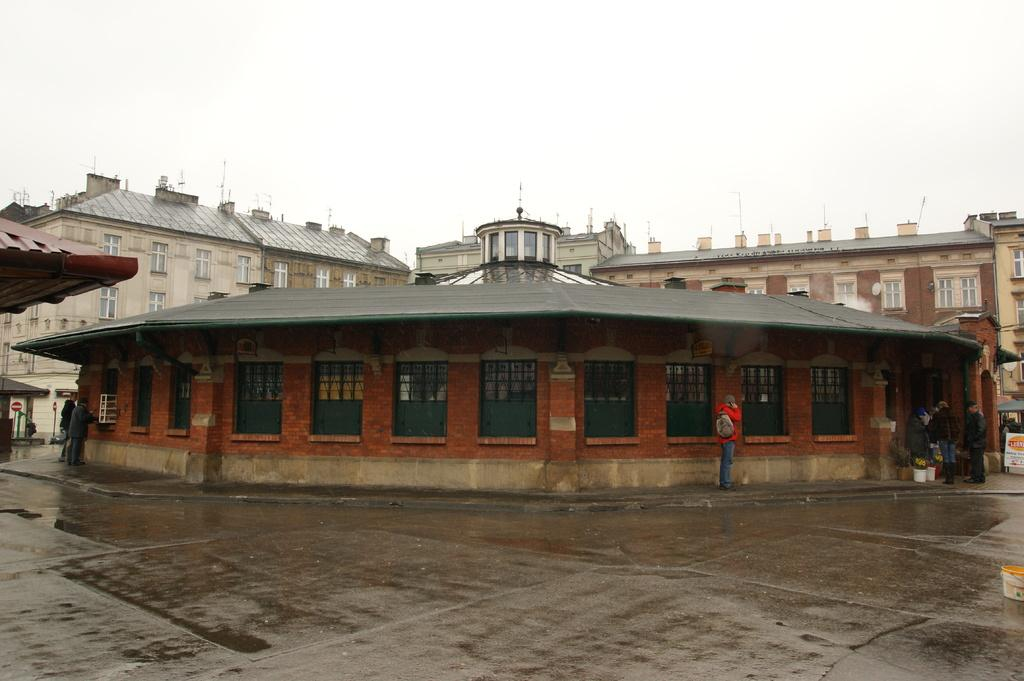What type of structures are visible in the image? There are buildings with windows in the image. What can be seen on the buildings in the image? There are sign boards on the buildings in the image. Who or what is present on the ground in the image? There are people standing on the ground in the image. What is visible above the buildings in the image? The sky is visible in the image. How many corks can be seen floating in the sky in the image? There are no corks visible in the image, as it features buildings, sign boards, people, and the sky. 